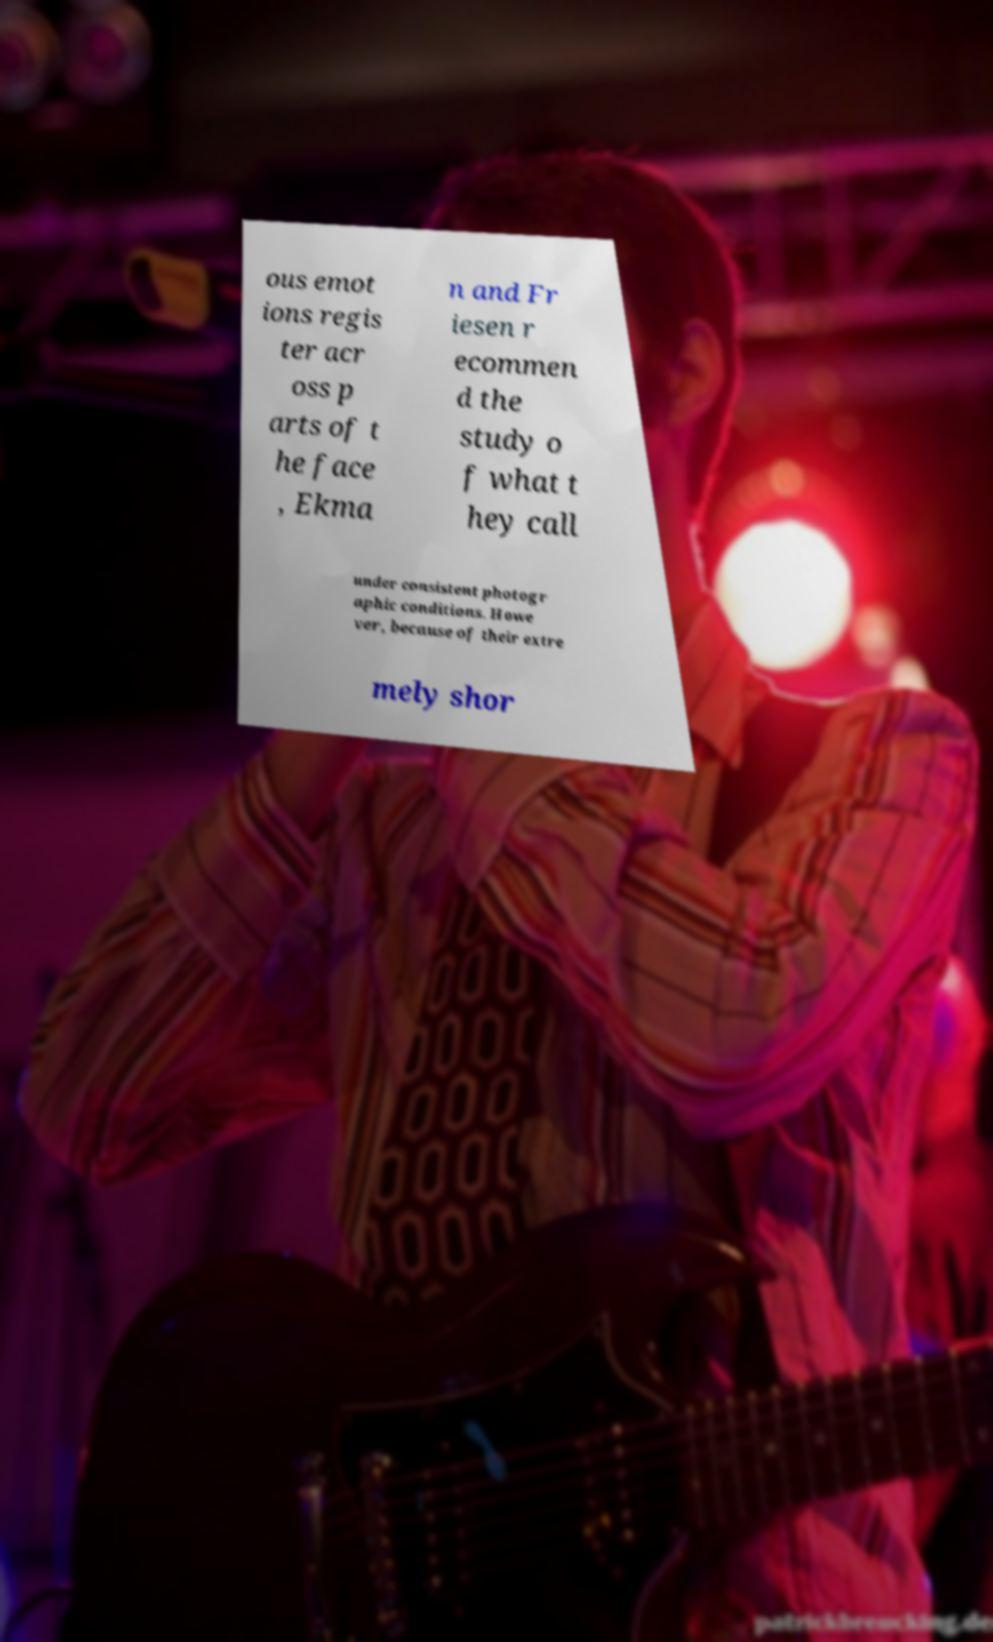What messages or text are displayed in this image? I need them in a readable, typed format. ous emot ions regis ter acr oss p arts of t he face , Ekma n and Fr iesen r ecommen d the study o f what t hey call under consistent photogr aphic conditions. Howe ver, because of their extre mely shor 